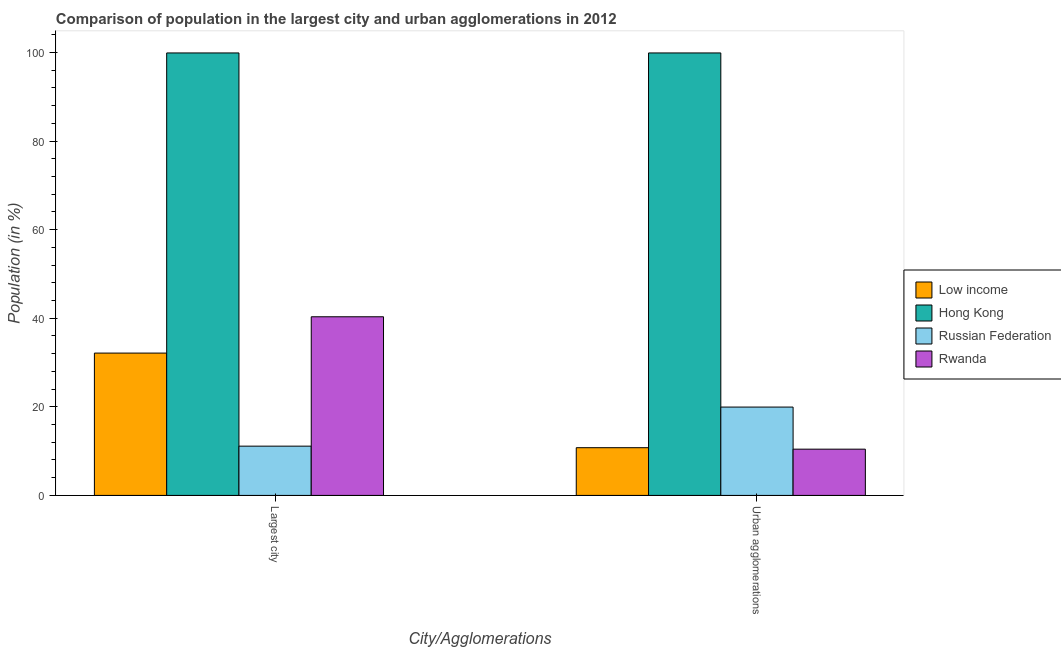How many groups of bars are there?
Offer a very short reply. 2. Are the number of bars per tick equal to the number of legend labels?
Ensure brevity in your answer.  Yes. How many bars are there on the 1st tick from the right?
Your answer should be very brief. 4. What is the label of the 2nd group of bars from the left?
Make the answer very short. Urban agglomerations. What is the population in the largest city in Russian Federation?
Keep it short and to the point. 11.13. Across all countries, what is the maximum population in the largest city?
Offer a very short reply. 99.91. Across all countries, what is the minimum population in urban agglomerations?
Provide a short and direct response. 10.45. In which country was the population in the largest city maximum?
Offer a terse response. Hong Kong. In which country was the population in urban agglomerations minimum?
Offer a very short reply. Rwanda. What is the total population in the largest city in the graph?
Ensure brevity in your answer.  183.52. What is the difference between the population in the largest city in Low income and that in Rwanda?
Offer a terse response. -8.2. What is the difference between the population in the largest city in Low income and the population in urban agglomerations in Rwanda?
Your response must be concise. 21.69. What is the average population in urban agglomerations per country?
Your answer should be very brief. 35.27. What is the difference between the population in urban agglomerations and population in the largest city in Russian Federation?
Ensure brevity in your answer.  8.82. In how many countries, is the population in the largest city greater than 96 %?
Ensure brevity in your answer.  1. What is the ratio of the population in urban agglomerations in Low income to that in Rwanda?
Provide a succinct answer. 1.03. Is the population in urban agglomerations in Low income less than that in Hong Kong?
Make the answer very short. Yes. In how many countries, is the population in the largest city greater than the average population in the largest city taken over all countries?
Ensure brevity in your answer.  1. What does the 2nd bar from the left in Largest city represents?
Your answer should be compact. Hong Kong. What does the 2nd bar from the right in Largest city represents?
Your answer should be very brief. Russian Federation. How many bars are there?
Your response must be concise. 8. Are all the bars in the graph horizontal?
Ensure brevity in your answer.  No. Does the graph contain any zero values?
Provide a succinct answer. No. Where does the legend appear in the graph?
Offer a very short reply. Center right. How many legend labels are there?
Make the answer very short. 4. How are the legend labels stacked?
Provide a succinct answer. Vertical. What is the title of the graph?
Make the answer very short. Comparison of population in the largest city and urban agglomerations in 2012. Does "Hungary" appear as one of the legend labels in the graph?
Your answer should be compact. No. What is the label or title of the X-axis?
Ensure brevity in your answer.  City/Agglomerations. What is the Population (in %) of Low income in Largest city?
Offer a terse response. 32.14. What is the Population (in %) of Hong Kong in Largest city?
Ensure brevity in your answer.  99.91. What is the Population (in %) of Russian Federation in Largest city?
Offer a very short reply. 11.13. What is the Population (in %) in Rwanda in Largest city?
Ensure brevity in your answer.  40.34. What is the Population (in %) of Low income in Urban agglomerations?
Ensure brevity in your answer.  10.78. What is the Population (in %) of Hong Kong in Urban agglomerations?
Keep it short and to the point. 99.91. What is the Population (in %) of Russian Federation in Urban agglomerations?
Make the answer very short. 19.95. What is the Population (in %) in Rwanda in Urban agglomerations?
Keep it short and to the point. 10.45. Across all City/Agglomerations, what is the maximum Population (in %) of Low income?
Give a very brief answer. 32.14. Across all City/Agglomerations, what is the maximum Population (in %) in Hong Kong?
Provide a succinct answer. 99.91. Across all City/Agglomerations, what is the maximum Population (in %) in Russian Federation?
Your response must be concise. 19.95. Across all City/Agglomerations, what is the maximum Population (in %) in Rwanda?
Your response must be concise. 40.34. Across all City/Agglomerations, what is the minimum Population (in %) of Low income?
Offer a terse response. 10.78. Across all City/Agglomerations, what is the minimum Population (in %) in Hong Kong?
Offer a very short reply. 99.91. Across all City/Agglomerations, what is the minimum Population (in %) in Russian Federation?
Give a very brief answer. 11.13. Across all City/Agglomerations, what is the minimum Population (in %) in Rwanda?
Provide a succinct answer. 10.45. What is the total Population (in %) of Low income in the graph?
Provide a succinct answer. 42.92. What is the total Population (in %) of Hong Kong in the graph?
Give a very brief answer. 199.83. What is the total Population (in %) in Russian Federation in the graph?
Your response must be concise. 31.08. What is the total Population (in %) of Rwanda in the graph?
Keep it short and to the point. 50.79. What is the difference between the Population (in %) in Low income in Largest city and that in Urban agglomerations?
Provide a short and direct response. 21.36. What is the difference between the Population (in %) in Hong Kong in Largest city and that in Urban agglomerations?
Ensure brevity in your answer.  0. What is the difference between the Population (in %) in Russian Federation in Largest city and that in Urban agglomerations?
Ensure brevity in your answer.  -8.82. What is the difference between the Population (in %) in Rwanda in Largest city and that in Urban agglomerations?
Offer a terse response. 29.89. What is the difference between the Population (in %) in Low income in Largest city and the Population (in %) in Hong Kong in Urban agglomerations?
Make the answer very short. -67.77. What is the difference between the Population (in %) in Low income in Largest city and the Population (in %) in Russian Federation in Urban agglomerations?
Your answer should be very brief. 12.19. What is the difference between the Population (in %) of Low income in Largest city and the Population (in %) of Rwanda in Urban agglomerations?
Ensure brevity in your answer.  21.69. What is the difference between the Population (in %) in Hong Kong in Largest city and the Population (in %) in Russian Federation in Urban agglomerations?
Provide a succinct answer. 79.96. What is the difference between the Population (in %) of Hong Kong in Largest city and the Population (in %) of Rwanda in Urban agglomerations?
Provide a succinct answer. 89.47. What is the difference between the Population (in %) of Russian Federation in Largest city and the Population (in %) of Rwanda in Urban agglomerations?
Offer a very short reply. 0.68. What is the average Population (in %) in Low income per City/Agglomerations?
Make the answer very short. 21.46. What is the average Population (in %) of Hong Kong per City/Agglomerations?
Make the answer very short. 99.91. What is the average Population (in %) of Russian Federation per City/Agglomerations?
Give a very brief answer. 15.54. What is the average Population (in %) of Rwanda per City/Agglomerations?
Make the answer very short. 25.39. What is the difference between the Population (in %) in Low income and Population (in %) in Hong Kong in Largest city?
Your answer should be very brief. -67.77. What is the difference between the Population (in %) in Low income and Population (in %) in Russian Federation in Largest city?
Your response must be concise. 21.01. What is the difference between the Population (in %) of Low income and Population (in %) of Rwanda in Largest city?
Keep it short and to the point. -8.2. What is the difference between the Population (in %) in Hong Kong and Population (in %) in Russian Federation in Largest city?
Provide a short and direct response. 88.79. What is the difference between the Population (in %) of Hong Kong and Population (in %) of Rwanda in Largest city?
Keep it short and to the point. 59.57. What is the difference between the Population (in %) in Russian Federation and Population (in %) in Rwanda in Largest city?
Make the answer very short. -29.21. What is the difference between the Population (in %) of Low income and Population (in %) of Hong Kong in Urban agglomerations?
Your answer should be very brief. -89.14. What is the difference between the Population (in %) of Low income and Population (in %) of Russian Federation in Urban agglomerations?
Your answer should be compact. -9.17. What is the difference between the Population (in %) of Low income and Population (in %) of Rwanda in Urban agglomerations?
Your answer should be very brief. 0.33. What is the difference between the Population (in %) in Hong Kong and Population (in %) in Russian Federation in Urban agglomerations?
Ensure brevity in your answer.  79.96. What is the difference between the Population (in %) in Hong Kong and Population (in %) in Rwanda in Urban agglomerations?
Offer a very short reply. 89.47. What is the difference between the Population (in %) in Russian Federation and Population (in %) in Rwanda in Urban agglomerations?
Keep it short and to the point. 9.51. What is the ratio of the Population (in %) in Low income in Largest city to that in Urban agglomerations?
Your response must be concise. 2.98. What is the ratio of the Population (in %) of Hong Kong in Largest city to that in Urban agglomerations?
Provide a short and direct response. 1. What is the ratio of the Population (in %) of Russian Federation in Largest city to that in Urban agglomerations?
Keep it short and to the point. 0.56. What is the ratio of the Population (in %) of Rwanda in Largest city to that in Urban agglomerations?
Provide a succinct answer. 3.86. What is the difference between the highest and the second highest Population (in %) of Low income?
Ensure brevity in your answer.  21.36. What is the difference between the highest and the second highest Population (in %) of Russian Federation?
Your answer should be compact. 8.82. What is the difference between the highest and the second highest Population (in %) in Rwanda?
Provide a succinct answer. 29.89. What is the difference between the highest and the lowest Population (in %) in Low income?
Make the answer very short. 21.36. What is the difference between the highest and the lowest Population (in %) of Russian Federation?
Ensure brevity in your answer.  8.82. What is the difference between the highest and the lowest Population (in %) of Rwanda?
Ensure brevity in your answer.  29.89. 